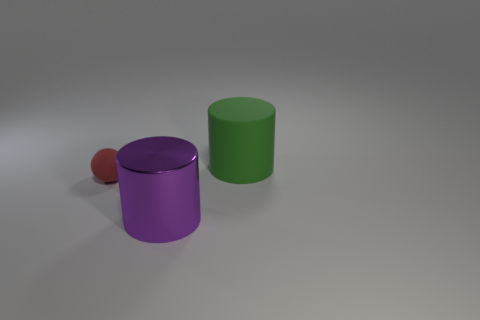What number of objects are small matte balls left of the big green rubber cylinder or small yellow objects?
Your answer should be very brief. 1. Are there any other red objects of the same shape as the metallic object?
Offer a very short reply. No. There is a green matte thing that is the same size as the shiny thing; what is its shape?
Keep it short and to the point. Cylinder. The small rubber object on the left side of the big cylinder that is in front of the cylinder right of the shiny thing is what shape?
Make the answer very short. Sphere. There is a green rubber thing; is its shape the same as the big thing that is in front of the green rubber cylinder?
Ensure brevity in your answer.  Yes. How many large objects are either cyan metal balls or red spheres?
Offer a terse response. 0. Are there any shiny cylinders that have the same size as the red matte object?
Your response must be concise. No. There is a thing that is right of the large object that is to the left of the cylinder to the right of the purple cylinder; what is its color?
Give a very brief answer. Green. Do the green object and the large cylinder that is in front of the ball have the same material?
Offer a terse response. No. Are there an equal number of purple shiny objects behind the large purple metal thing and tiny matte things that are left of the tiny matte sphere?
Provide a succinct answer. Yes. 